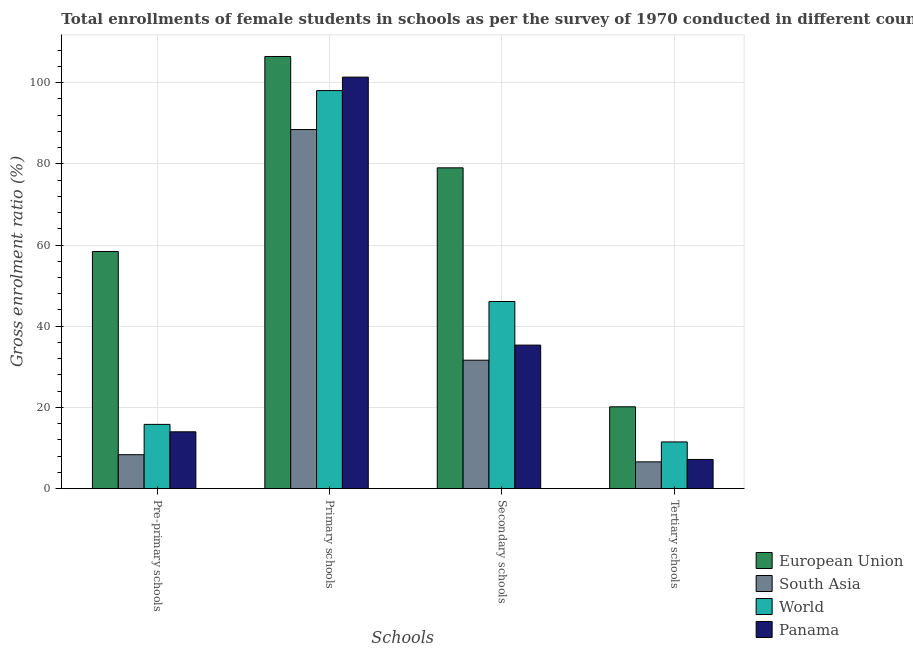How many groups of bars are there?
Offer a very short reply. 4. Are the number of bars per tick equal to the number of legend labels?
Your answer should be compact. Yes. How many bars are there on the 2nd tick from the left?
Give a very brief answer. 4. How many bars are there on the 3rd tick from the right?
Give a very brief answer. 4. What is the label of the 4th group of bars from the left?
Provide a short and direct response. Tertiary schools. What is the gross enrolment ratio(female) in tertiary schools in European Union?
Keep it short and to the point. 20.16. Across all countries, what is the maximum gross enrolment ratio(female) in pre-primary schools?
Your answer should be very brief. 58.41. Across all countries, what is the minimum gross enrolment ratio(female) in primary schools?
Offer a very short reply. 88.43. In which country was the gross enrolment ratio(female) in secondary schools maximum?
Provide a succinct answer. European Union. What is the total gross enrolment ratio(female) in pre-primary schools in the graph?
Provide a short and direct response. 96.61. What is the difference between the gross enrolment ratio(female) in secondary schools in World and that in Panama?
Your answer should be very brief. 10.73. What is the difference between the gross enrolment ratio(female) in pre-primary schools in South Asia and the gross enrolment ratio(female) in primary schools in World?
Ensure brevity in your answer.  -89.66. What is the average gross enrolment ratio(female) in tertiary schools per country?
Make the answer very short. 11.37. What is the difference between the gross enrolment ratio(female) in primary schools and gross enrolment ratio(female) in secondary schools in South Asia?
Offer a terse response. 56.8. What is the ratio of the gross enrolment ratio(female) in secondary schools in World to that in South Asia?
Provide a short and direct response. 1.46. What is the difference between the highest and the second highest gross enrolment ratio(female) in primary schools?
Offer a very short reply. 5.08. What is the difference between the highest and the lowest gross enrolment ratio(female) in primary schools?
Your answer should be compact. 17.99. In how many countries, is the gross enrolment ratio(female) in secondary schools greater than the average gross enrolment ratio(female) in secondary schools taken over all countries?
Give a very brief answer. 1. Is the sum of the gross enrolment ratio(female) in pre-primary schools in World and South Asia greater than the maximum gross enrolment ratio(female) in primary schools across all countries?
Keep it short and to the point. No. Is it the case that in every country, the sum of the gross enrolment ratio(female) in tertiary schools and gross enrolment ratio(female) in secondary schools is greater than the sum of gross enrolment ratio(female) in primary schools and gross enrolment ratio(female) in pre-primary schools?
Give a very brief answer. No. What does the 3rd bar from the left in Secondary schools represents?
Offer a terse response. World. Are all the bars in the graph horizontal?
Give a very brief answer. No. How many countries are there in the graph?
Ensure brevity in your answer.  4. What is the difference between two consecutive major ticks on the Y-axis?
Your answer should be compact. 20. Are the values on the major ticks of Y-axis written in scientific E-notation?
Your answer should be very brief. No. Does the graph contain any zero values?
Your answer should be very brief. No. Does the graph contain grids?
Give a very brief answer. Yes. Where does the legend appear in the graph?
Offer a terse response. Bottom right. How many legend labels are there?
Ensure brevity in your answer.  4. How are the legend labels stacked?
Make the answer very short. Vertical. What is the title of the graph?
Give a very brief answer. Total enrollments of female students in schools as per the survey of 1970 conducted in different countries. What is the label or title of the X-axis?
Offer a very short reply. Schools. What is the Gross enrolment ratio (%) of European Union in Pre-primary schools?
Offer a terse response. 58.41. What is the Gross enrolment ratio (%) in South Asia in Pre-primary schools?
Make the answer very short. 8.37. What is the Gross enrolment ratio (%) of World in Pre-primary schools?
Your answer should be very brief. 15.83. What is the Gross enrolment ratio (%) of Panama in Pre-primary schools?
Your response must be concise. 14. What is the Gross enrolment ratio (%) in European Union in Primary schools?
Your response must be concise. 106.42. What is the Gross enrolment ratio (%) of South Asia in Primary schools?
Provide a short and direct response. 88.43. What is the Gross enrolment ratio (%) of World in Primary schools?
Your answer should be compact. 98.02. What is the Gross enrolment ratio (%) of Panama in Primary schools?
Offer a terse response. 101.34. What is the Gross enrolment ratio (%) of European Union in Secondary schools?
Ensure brevity in your answer.  79.01. What is the Gross enrolment ratio (%) in South Asia in Secondary schools?
Keep it short and to the point. 31.64. What is the Gross enrolment ratio (%) in World in Secondary schools?
Make the answer very short. 46.09. What is the Gross enrolment ratio (%) of Panama in Secondary schools?
Your answer should be very brief. 35.36. What is the Gross enrolment ratio (%) of European Union in Tertiary schools?
Provide a succinct answer. 20.16. What is the Gross enrolment ratio (%) in South Asia in Tertiary schools?
Your response must be concise. 6.6. What is the Gross enrolment ratio (%) in World in Tertiary schools?
Offer a very short reply. 11.51. What is the Gross enrolment ratio (%) in Panama in Tertiary schools?
Provide a short and direct response. 7.19. Across all Schools, what is the maximum Gross enrolment ratio (%) of European Union?
Make the answer very short. 106.42. Across all Schools, what is the maximum Gross enrolment ratio (%) of South Asia?
Give a very brief answer. 88.43. Across all Schools, what is the maximum Gross enrolment ratio (%) in World?
Provide a short and direct response. 98.02. Across all Schools, what is the maximum Gross enrolment ratio (%) of Panama?
Ensure brevity in your answer.  101.34. Across all Schools, what is the minimum Gross enrolment ratio (%) of European Union?
Offer a terse response. 20.16. Across all Schools, what is the minimum Gross enrolment ratio (%) of South Asia?
Offer a terse response. 6.6. Across all Schools, what is the minimum Gross enrolment ratio (%) of World?
Your response must be concise. 11.51. Across all Schools, what is the minimum Gross enrolment ratio (%) of Panama?
Offer a terse response. 7.19. What is the total Gross enrolment ratio (%) in European Union in the graph?
Your answer should be compact. 264. What is the total Gross enrolment ratio (%) in South Asia in the graph?
Give a very brief answer. 135.04. What is the total Gross enrolment ratio (%) of World in the graph?
Make the answer very short. 171.45. What is the total Gross enrolment ratio (%) of Panama in the graph?
Your answer should be compact. 157.9. What is the difference between the Gross enrolment ratio (%) of European Union in Pre-primary schools and that in Primary schools?
Your answer should be compact. -48.02. What is the difference between the Gross enrolment ratio (%) in South Asia in Pre-primary schools and that in Primary schools?
Keep it short and to the point. -80.07. What is the difference between the Gross enrolment ratio (%) of World in Pre-primary schools and that in Primary schools?
Give a very brief answer. -82.19. What is the difference between the Gross enrolment ratio (%) of Panama in Pre-primary schools and that in Primary schools?
Your response must be concise. -87.34. What is the difference between the Gross enrolment ratio (%) of European Union in Pre-primary schools and that in Secondary schools?
Offer a very short reply. -20.6. What is the difference between the Gross enrolment ratio (%) in South Asia in Pre-primary schools and that in Secondary schools?
Your response must be concise. -23.27. What is the difference between the Gross enrolment ratio (%) in World in Pre-primary schools and that in Secondary schools?
Ensure brevity in your answer.  -30.26. What is the difference between the Gross enrolment ratio (%) in Panama in Pre-primary schools and that in Secondary schools?
Your response must be concise. -21.35. What is the difference between the Gross enrolment ratio (%) of European Union in Pre-primary schools and that in Tertiary schools?
Make the answer very short. 38.24. What is the difference between the Gross enrolment ratio (%) in South Asia in Pre-primary schools and that in Tertiary schools?
Your answer should be compact. 1.76. What is the difference between the Gross enrolment ratio (%) of World in Pre-primary schools and that in Tertiary schools?
Provide a succinct answer. 4.32. What is the difference between the Gross enrolment ratio (%) in Panama in Pre-primary schools and that in Tertiary schools?
Provide a succinct answer. 6.81. What is the difference between the Gross enrolment ratio (%) of European Union in Primary schools and that in Secondary schools?
Make the answer very short. 27.42. What is the difference between the Gross enrolment ratio (%) in South Asia in Primary schools and that in Secondary schools?
Your answer should be compact. 56.8. What is the difference between the Gross enrolment ratio (%) in World in Primary schools and that in Secondary schools?
Keep it short and to the point. 51.93. What is the difference between the Gross enrolment ratio (%) in Panama in Primary schools and that in Secondary schools?
Provide a short and direct response. 65.99. What is the difference between the Gross enrolment ratio (%) of European Union in Primary schools and that in Tertiary schools?
Ensure brevity in your answer.  86.26. What is the difference between the Gross enrolment ratio (%) of South Asia in Primary schools and that in Tertiary schools?
Ensure brevity in your answer.  81.83. What is the difference between the Gross enrolment ratio (%) of World in Primary schools and that in Tertiary schools?
Offer a very short reply. 86.51. What is the difference between the Gross enrolment ratio (%) of Panama in Primary schools and that in Tertiary schools?
Your response must be concise. 94.15. What is the difference between the Gross enrolment ratio (%) in European Union in Secondary schools and that in Tertiary schools?
Provide a succinct answer. 58.85. What is the difference between the Gross enrolment ratio (%) in South Asia in Secondary schools and that in Tertiary schools?
Your answer should be compact. 25.03. What is the difference between the Gross enrolment ratio (%) of World in Secondary schools and that in Tertiary schools?
Keep it short and to the point. 34.58. What is the difference between the Gross enrolment ratio (%) in Panama in Secondary schools and that in Tertiary schools?
Keep it short and to the point. 28.16. What is the difference between the Gross enrolment ratio (%) of European Union in Pre-primary schools and the Gross enrolment ratio (%) of South Asia in Primary schools?
Provide a short and direct response. -30.03. What is the difference between the Gross enrolment ratio (%) of European Union in Pre-primary schools and the Gross enrolment ratio (%) of World in Primary schools?
Your answer should be compact. -39.62. What is the difference between the Gross enrolment ratio (%) in European Union in Pre-primary schools and the Gross enrolment ratio (%) in Panama in Primary schools?
Ensure brevity in your answer.  -42.94. What is the difference between the Gross enrolment ratio (%) in South Asia in Pre-primary schools and the Gross enrolment ratio (%) in World in Primary schools?
Keep it short and to the point. -89.66. What is the difference between the Gross enrolment ratio (%) of South Asia in Pre-primary schools and the Gross enrolment ratio (%) of Panama in Primary schools?
Provide a succinct answer. -92.98. What is the difference between the Gross enrolment ratio (%) of World in Pre-primary schools and the Gross enrolment ratio (%) of Panama in Primary schools?
Offer a terse response. -85.51. What is the difference between the Gross enrolment ratio (%) of European Union in Pre-primary schools and the Gross enrolment ratio (%) of South Asia in Secondary schools?
Offer a terse response. 26.77. What is the difference between the Gross enrolment ratio (%) in European Union in Pre-primary schools and the Gross enrolment ratio (%) in World in Secondary schools?
Your answer should be compact. 12.32. What is the difference between the Gross enrolment ratio (%) of European Union in Pre-primary schools and the Gross enrolment ratio (%) of Panama in Secondary schools?
Provide a short and direct response. 23.05. What is the difference between the Gross enrolment ratio (%) of South Asia in Pre-primary schools and the Gross enrolment ratio (%) of World in Secondary schools?
Your response must be concise. -37.72. What is the difference between the Gross enrolment ratio (%) of South Asia in Pre-primary schools and the Gross enrolment ratio (%) of Panama in Secondary schools?
Your answer should be compact. -26.99. What is the difference between the Gross enrolment ratio (%) in World in Pre-primary schools and the Gross enrolment ratio (%) in Panama in Secondary schools?
Make the answer very short. -19.52. What is the difference between the Gross enrolment ratio (%) in European Union in Pre-primary schools and the Gross enrolment ratio (%) in South Asia in Tertiary schools?
Your response must be concise. 51.8. What is the difference between the Gross enrolment ratio (%) of European Union in Pre-primary schools and the Gross enrolment ratio (%) of World in Tertiary schools?
Your answer should be very brief. 46.89. What is the difference between the Gross enrolment ratio (%) in European Union in Pre-primary schools and the Gross enrolment ratio (%) in Panama in Tertiary schools?
Provide a short and direct response. 51.21. What is the difference between the Gross enrolment ratio (%) in South Asia in Pre-primary schools and the Gross enrolment ratio (%) in World in Tertiary schools?
Give a very brief answer. -3.14. What is the difference between the Gross enrolment ratio (%) in South Asia in Pre-primary schools and the Gross enrolment ratio (%) in Panama in Tertiary schools?
Make the answer very short. 1.17. What is the difference between the Gross enrolment ratio (%) of World in Pre-primary schools and the Gross enrolment ratio (%) of Panama in Tertiary schools?
Provide a succinct answer. 8.64. What is the difference between the Gross enrolment ratio (%) in European Union in Primary schools and the Gross enrolment ratio (%) in South Asia in Secondary schools?
Offer a very short reply. 74.79. What is the difference between the Gross enrolment ratio (%) in European Union in Primary schools and the Gross enrolment ratio (%) in World in Secondary schools?
Your answer should be compact. 60.33. What is the difference between the Gross enrolment ratio (%) in European Union in Primary schools and the Gross enrolment ratio (%) in Panama in Secondary schools?
Keep it short and to the point. 71.07. What is the difference between the Gross enrolment ratio (%) in South Asia in Primary schools and the Gross enrolment ratio (%) in World in Secondary schools?
Your answer should be very brief. 42.34. What is the difference between the Gross enrolment ratio (%) in South Asia in Primary schools and the Gross enrolment ratio (%) in Panama in Secondary schools?
Provide a succinct answer. 53.08. What is the difference between the Gross enrolment ratio (%) of World in Primary schools and the Gross enrolment ratio (%) of Panama in Secondary schools?
Make the answer very short. 62.67. What is the difference between the Gross enrolment ratio (%) of European Union in Primary schools and the Gross enrolment ratio (%) of South Asia in Tertiary schools?
Offer a terse response. 99.82. What is the difference between the Gross enrolment ratio (%) in European Union in Primary schools and the Gross enrolment ratio (%) in World in Tertiary schools?
Your response must be concise. 94.91. What is the difference between the Gross enrolment ratio (%) in European Union in Primary schools and the Gross enrolment ratio (%) in Panama in Tertiary schools?
Give a very brief answer. 99.23. What is the difference between the Gross enrolment ratio (%) in South Asia in Primary schools and the Gross enrolment ratio (%) in World in Tertiary schools?
Your answer should be very brief. 76.92. What is the difference between the Gross enrolment ratio (%) in South Asia in Primary schools and the Gross enrolment ratio (%) in Panama in Tertiary schools?
Provide a short and direct response. 81.24. What is the difference between the Gross enrolment ratio (%) of World in Primary schools and the Gross enrolment ratio (%) of Panama in Tertiary schools?
Give a very brief answer. 90.83. What is the difference between the Gross enrolment ratio (%) of European Union in Secondary schools and the Gross enrolment ratio (%) of South Asia in Tertiary schools?
Your answer should be compact. 72.4. What is the difference between the Gross enrolment ratio (%) of European Union in Secondary schools and the Gross enrolment ratio (%) of World in Tertiary schools?
Provide a succinct answer. 67.5. What is the difference between the Gross enrolment ratio (%) in European Union in Secondary schools and the Gross enrolment ratio (%) in Panama in Tertiary schools?
Offer a very short reply. 71.81. What is the difference between the Gross enrolment ratio (%) of South Asia in Secondary schools and the Gross enrolment ratio (%) of World in Tertiary schools?
Ensure brevity in your answer.  20.13. What is the difference between the Gross enrolment ratio (%) of South Asia in Secondary schools and the Gross enrolment ratio (%) of Panama in Tertiary schools?
Offer a terse response. 24.44. What is the difference between the Gross enrolment ratio (%) of World in Secondary schools and the Gross enrolment ratio (%) of Panama in Tertiary schools?
Offer a very short reply. 38.9. What is the average Gross enrolment ratio (%) of European Union per Schools?
Provide a succinct answer. 66. What is the average Gross enrolment ratio (%) in South Asia per Schools?
Provide a succinct answer. 33.76. What is the average Gross enrolment ratio (%) of World per Schools?
Your answer should be very brief. 42.86. What is the average Gross enrolment ratio (%) in Panama per Schools?
Provide a short and direct response. 39.47. What is the difference between the Gross enrolment ratio (%) of European Union and Gross enrolment ratio (%) of South Asia in Pre-primary schools?
Ensure brevity in your answer.  50.04. What is the difference between the Gross enrolment ratio (%) of European Union and Gross enrolment ratio (%) of World in Pre-primary schools?
Offer a terse response. 42.57. What is the difference between the Gross enrolment ratio (%) in European Union and Gross enrolment ratio (%) in Panama in Pre-primary schools?
Ensure brevity in your answer.  44.4. What is the difference between the Gross enrolment ratio (%) of South Asia and Gross enrolment ratio (%) of World in Pre-primary schools?
Your response must be concise. -7.46. What is the difference between the Gross enrolment ratio (%) in South Asia and Gross enrolment ratio (%) in Panama in Pre-primary schools?
Give a very brief answer. -5.64. What is the difference between the Gross enrolment ratio (%) in World and Gross enrolment ratio (%) in Panama in Pre-primary schools?
Make the answer very short. 1.83. What is the difference between the Gross enrolment ratio (%) in European Union and Gross enrolment ratio (%) in South Asia in Primary schools?
Offer a very short reply. 17.99. What is the difference between the Gross enrolment ratio (%) in European Union and Gross enrolment ratio (%) in World in Primary schools?
Ensure brevity in your answer.  8.4. What is the difference between the Gross enrolment ratio (%) in European Union and Gross enrolment ratio (%) in Panama in Primary schools?
Provide a short and direct response. 5.08. What is the difference between the Gross enrolment ratio (%) in South Asia and Gross enrolment ratio (%) in World in Primary schools?
Your answer should be very brief. -9.59. What is the difference between the Gross enrolment ratio (%) of South Asia and Gross enrolment ratio (%) of Panama in Primary schools?
Give a very brief answer. -12.91. What is the difference between the Gross enrolment ratio (%) in World and Gross enrolment ratio (%) in Panama in Primary schools?
Offer a very short reply. -3.32. What is the difference between the Gross enrolment ratio (%) of European Union and Gross enrolment ratio (%) of South Asia in Secondary schools?
Offer a very short reply. 47.37. What is the difference between the Gross enrolment ratio (%) in European Union and Gross enrolment ratio (%) in World in Secondary schools?
Provide a succinct answer. 32.92. What is the difference between the Gross enrolment ratio (%) in European Union and Gross enrolment ratio (%) in Panama in Secondary schools?
Provide a succinct answer. 43.65. What is the difference between the Gross enrolment ratio (%) of South Asia and Gross enrolment ratio (%) of World in Secondary schools?
Give a very brief answer. -14.45. What is the difference between the Gross enrolment ratio (%) in South Asia and Gross enrolment ratio (%) in Panama in Secondary schools?
Your response must be concise. -3.72. What is the difference between the Gross enrolment ratio (%) of World and Gross enrolment ratio (%) of Panama in Secondary schools?
Keep it short and to the point. 10.73. What is the difference between the Gross enrolment ratio (%) in European Union and Gross enrolment ratio (%) in South Asia in Tertiary schools?
Your answer should be very brief. 13.56. What is the difference between the Gross enrolment ratio (%) in European Union and Gross enrolment ratio (%) in World in Tertiary schools?
Keep it short and to the point. 8.65. What is the difference between the Gross enrolment ratio (%) of European Union and Gross enrolment ratio (%) of Panama in Tertiary schools?
Your answer should be very brief. 12.97. What is the difference between the Gross enrolment ratio (%) in South Asia and Gross enrolment ratio (%) in World in Tertiary schools?
Provide a short and direct response. -4.91. What is the difference between the Gross enrolment ratio (%) of South Asia and Gross enrolment ratio (%) of Panama in Tertiary schools?
Offer a very short reply. -0.59. What is the difference between the Gross enrolment ratio (%) in World and Gross enrolment ratio (%) in Panama in Tertiary schools?
Provide a short and direct response. 4.32. What is the ratio of the Gross enrolment ratio (%) in European Union in Pre-primary schools to that in Primary schools?
Offer a very short reply. 0.55. What is the ratio of the Gross enrolment ratio (%) of South Asia in Pre-primary schools to that in Primary schools?
Provide a succinct answer. 0.09. What is the ratio of the Gross enrolment ratio (%) in World in Pre-primary schools to that in Primary schools?
Provide a short and direct response. 0.16. What is the ratio of the Gross enrolment ratio (%) in Panama in Pre-primary schools to that in Primary schools?
Your answer should be compact. 0.14. What is the ratio of the Gross enrolment ratio (%) in European Union in Pre-primary schools to that in Secondary schools?
Make the answer very short. 0.74. What is the ratio of the Gross enrolment ratio (%) of South Asia in Pre-primary schools to that in Secondary schools?
Provide a short and direct response. 0.26. What is the ratio of the Gross enrolment ratio (%) in World in Pre-primary schools to that in Secondary schools?
Your response must be concise. 0.34. What is the ratio of the Gross enrolment ratio (%) in Panama in Pre-primary schools to that in Secondary schools?
Ensure brevity in your answer.  0.4. What is the ratio of the Gross enrolment ratio (%) of European Union in Pre-primary schools to that in Tertiary schools?
Ensure brevity in your answer.  2.9. What is the ratio of the Gross enrolment ratio (%) in South Asia in Pre-primary schools to that in Tertiary schools?
Give a very brief answer. 1.27. What is the ratio of the Gross enrolment ratio (%) of World in Pre-primary schools to that in Tertiary schools?
Provide a short and direct response. 1.38. What is the ratio of the Gross enrolment ratio (%) of Panama in Pre-primary schools to that in Tertiary schools?
Provide a short and direct response. 1.95. What is the ratio of the Gross enrolment ratio (%) of European Union in Primary schools to that in Secondary schools?
Offer a very short reply. 1.35. What is the ratio of the Gross enrolment ratio (%) in South Asia in Primary schools to that in Secondary schools?
Your answer should be very brief. 2.8. What is the ratio of the Gross enrolment ratio (%) of World in Primary schools to that in Secondary schools?
Offer a very short reply. 2.13. What is the ratio of the Gross enrolment ratio (%) of Panama in Primary schools to that in Secondary schools?
Give a very brief answer. 2.87. What is the ratio of the Gross enrolment ratio (%) in European Union in Primary schools to that in Tertiary schools?
Make the answer very short. 5.28. What is the ratio of the Gross enrolment ratio (%) in South Asia in Primary schools to that in Tertiary schools?
Your response must be concise. 13.39. What is the ratio of the Gross enrolment ratio (%) in World in Primary schools to that in Tertiary schools?
Your answer should be very brief. 8.52. What is the ratio of the Gross enrolment ratio (%) in Panama in Primary schools to that in Tertiary schools?
Give a very brief answer. 14.09. What is the ratio of the Gross enrolment ratio (%) of European Union in Secondary schools to that in Tertiary schools?
Ensure brevity in your answer.  3.92. What is the ratio of the Gross enrolment ratio (%) in South Asia in Secondary schools to that in Tertiary schools?
Offer a terse response. 4.79. What is the ratio of the Gross enrolment ratio (%) in World in Secondary schools to that in Tertiary schools?
Provide a succinct answer. 4. What is the ratio of the Gross enrolment ratio (%) of Panama in Secondary schools to that in Tertiary schools?
Provide a succinct answer. 4.91. What is the difference between the highest and the second highest Gross enrolment ratio (%) in European Union?
Your response must be concise. 27.42. What is the difference between the highest and the second highest Gross enrolment ratio (%) of South Asia?
Ensure brevity in your answer.  56.8. What is the difference between the highest and the second highest Gross enrolment ratio (%) in World?
Provide a succinct answer. 51.93. What is the difference between the highest and the second highest Gross enrolment ratio (%) of Panama?
Your answer should be compact. 65.99. What is the difference between the highest and the lowest Gross enrolment ratio (%) in European Union?
Make the answer very short. 86.26. What is the difference between the highest and the lowest Gross enrolment ratio (%) in South Asia?
Provide a succinct answer. 81.83. What is the difference between the highest and the lowest Gross enrolment ratio (%) in World?
Make the answer very short. 86.51. What is the difference between the highest and the lowest Gross enrolment ratio (%) in Panama?
Provide a short and direct response. 94.15. 